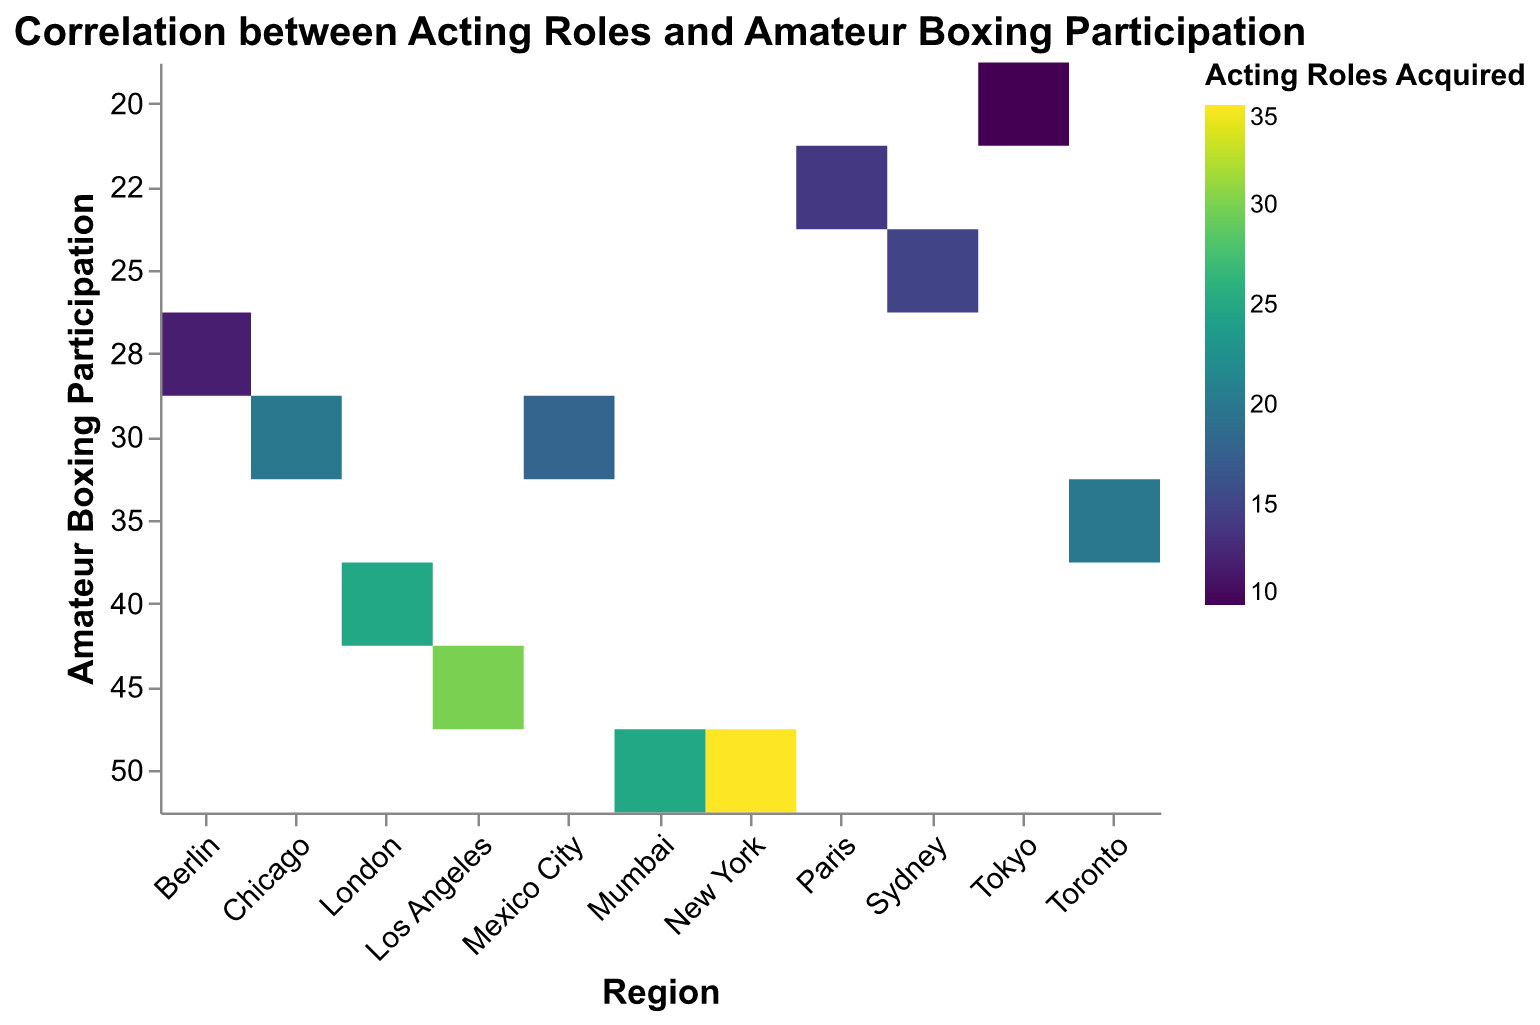What is the title of the figure? The title is usually located at the top of the figure. In this case, it shows the topic being analyzed.
Answer: Correlation between Acting Roles and Amateur Boxing Participation Which region has the highest number of Acting Roles Acquired? By looking at the colors representing the Acting Roles Acquired on the heatmap, you can identify which region has the highest value. A region with a darker color generally indicates a higher number of roles.
Answer: New York What is the Amateur Boxing Participation in Tokyo, and how many Acting Roles were acquired there? Find the cell that corresponds to Tokyo on the x-axis and check its value on both the y-axis and the color representing Acting Roles Acquired.
Answer: 20, 10 Which region has the lowest Amateur Boxing Participation but more than 10 Acting Roles Acquired? By sorting the regions for the lowest Amateur Boxing Participation and checking if their Acting Roles Acquired are more than 10, you can identify the region.
Answer: Tokyo How does the number of Acting Roles Acquired in Paris compare to that in Sydney? Compare the colors representing the Acting Roles Acquired in Paris and Sydney.
Answer: Paris has one more than Sydney What is the sum of Acting Roles Acquired in Los Angeles, New York, and Chicago? Add up the Acting Roles Acquired for these three regions by looking at their respective cells in the heatmap.
Answer: 85 Is Amateur Boxing Participation in London higher or lower than in Los Angeles? Compare the values on the y-axis for London and Los Angeles.
Answer: Lower What is the range of Acting Roles Acquired for regions with Amateur Boxing Participation between 20 and 30? Identify regions with Amateur Boxing Participation between 20 and 30 and find the minimum and maximum values of Acting Roles Acquired.
Answer: 10-18 Which region has the closest number of Acting Roles Acquired to that of Berlin? Compare the value of Acting Roles Acquired for Berlin with other regions to find the closest match.
Answer: Paris Which region shows a balanced number of Amateur Boxing Participation and Acting Roles Acquired? Look for a region where the values of Amateur Boxing Participation and Acting Roles Acquired are close to each other, indicating a balance.
Answer: Los Angeles 